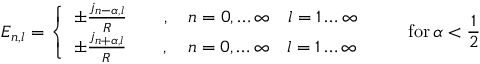Convert formula to latex. <formula><loc_0><loc_0><loc_500><loc_500>E _ { n , l } = \left \{ \begin{array} { l } { { \pm \frac { j _ { n - \alpha , l } } { R } \quad , \quad n = 0 , \dots \infty \quad l = 1 \dots \infty } } \\ { { \pm \frac { j _ { n + \alpha , l } } { R } \quad , \quad n = 0 , \dots \infty \quad l = 1 \dots \infty } } \end{array} \quad f o r \, \alpha < \frac { 1 } { 2 }</formula> 